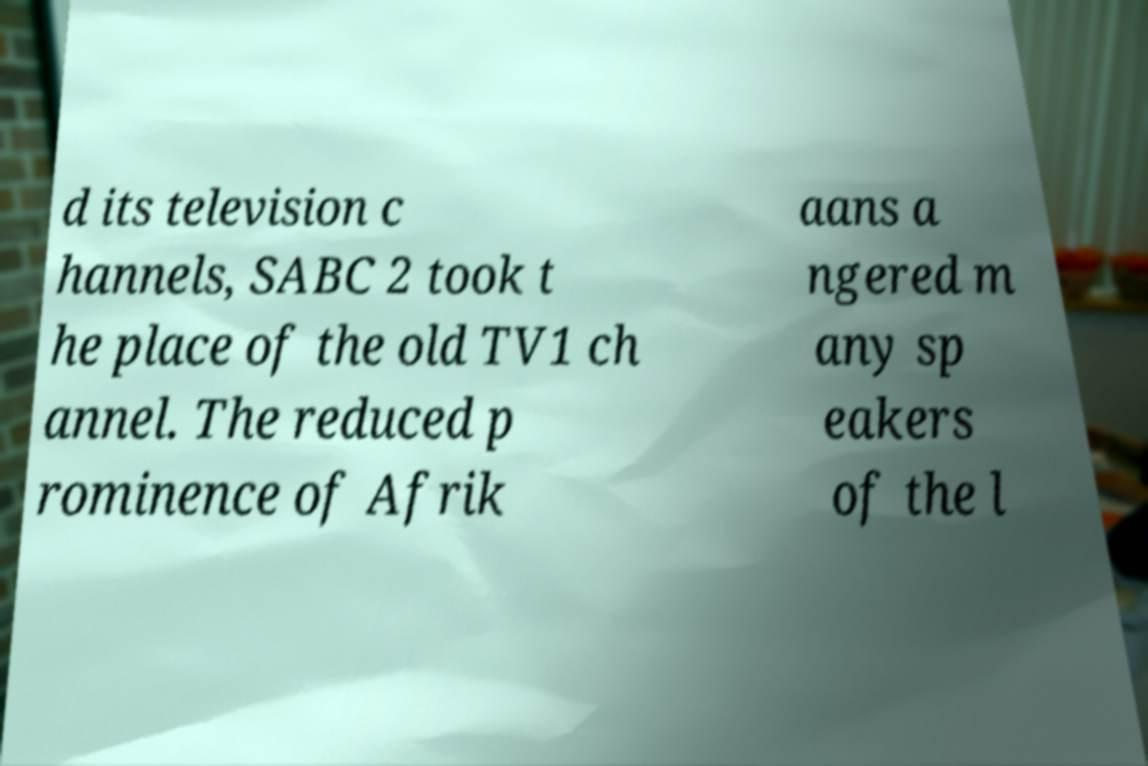There's text embedded in this image that I need extracted. Can you transcribe it verbatim? d its television c hannels, SABC 2 took t he place of the old TV1 ch annel. The reduced p rominence of Afrik aans a ngered m any sp eakers of the l 